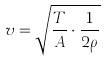<formula> <loc_0><loc_0><loc_500><loc_500>v = \sqrt { \frac { T } { A } \cdot \frac { 1 } { 2 \rho } }</formula> 